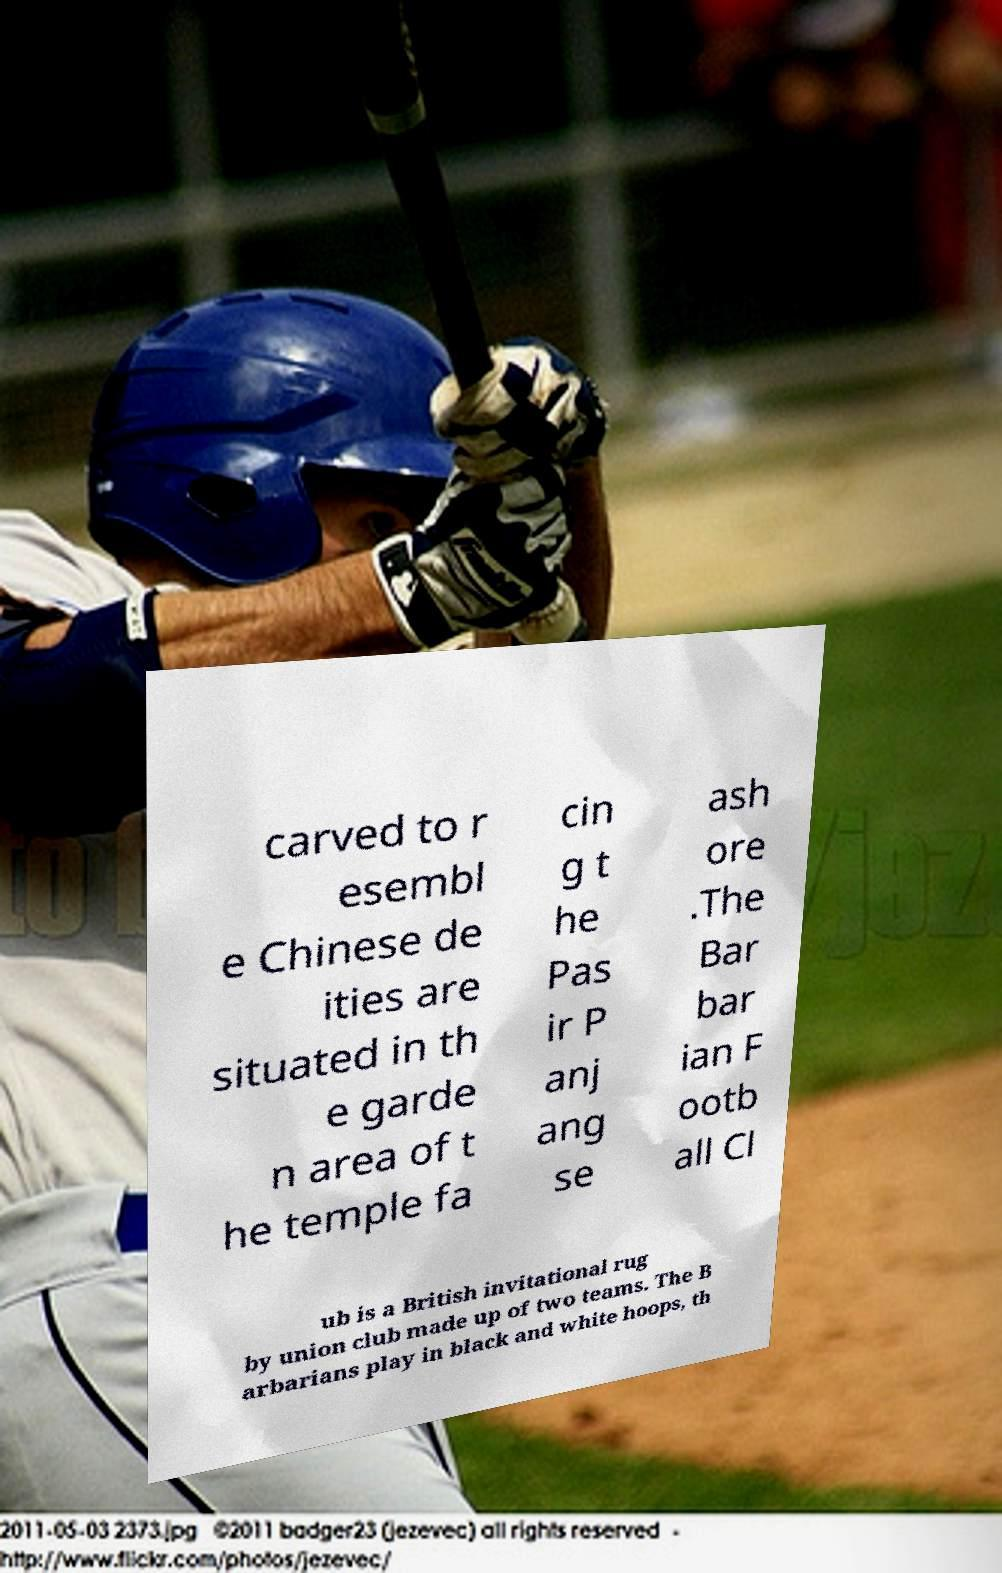What messages or text are displayed in this image? I need them in a readable, typed format. carved to r esembl e Chinese de ities are situated in th e garde n area of t he temple fa cin g t he Pas ir P anj ang se ash ore .The Bar bar ian F ootb all Cl ub is a British invitational rug by union club made up of two teams. The B arbarians play in black and white hoops, th 